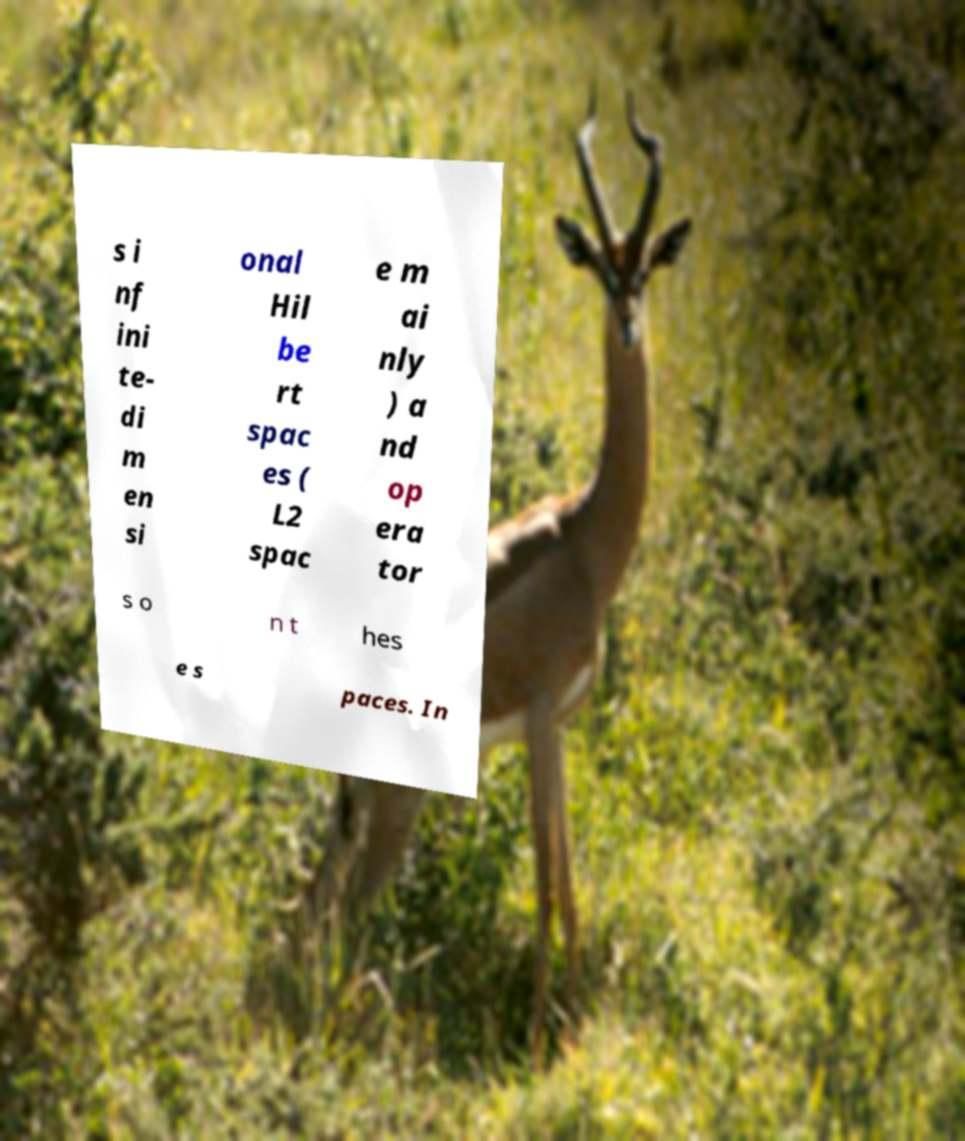What messages or text are displayed in this image? I need them in a readable, typed format. s i nf ini te- di m en si onal Hil be rt spac es ( L2 spac e m ai nly ) a nd op era tor s o n t hes e s paces. In 